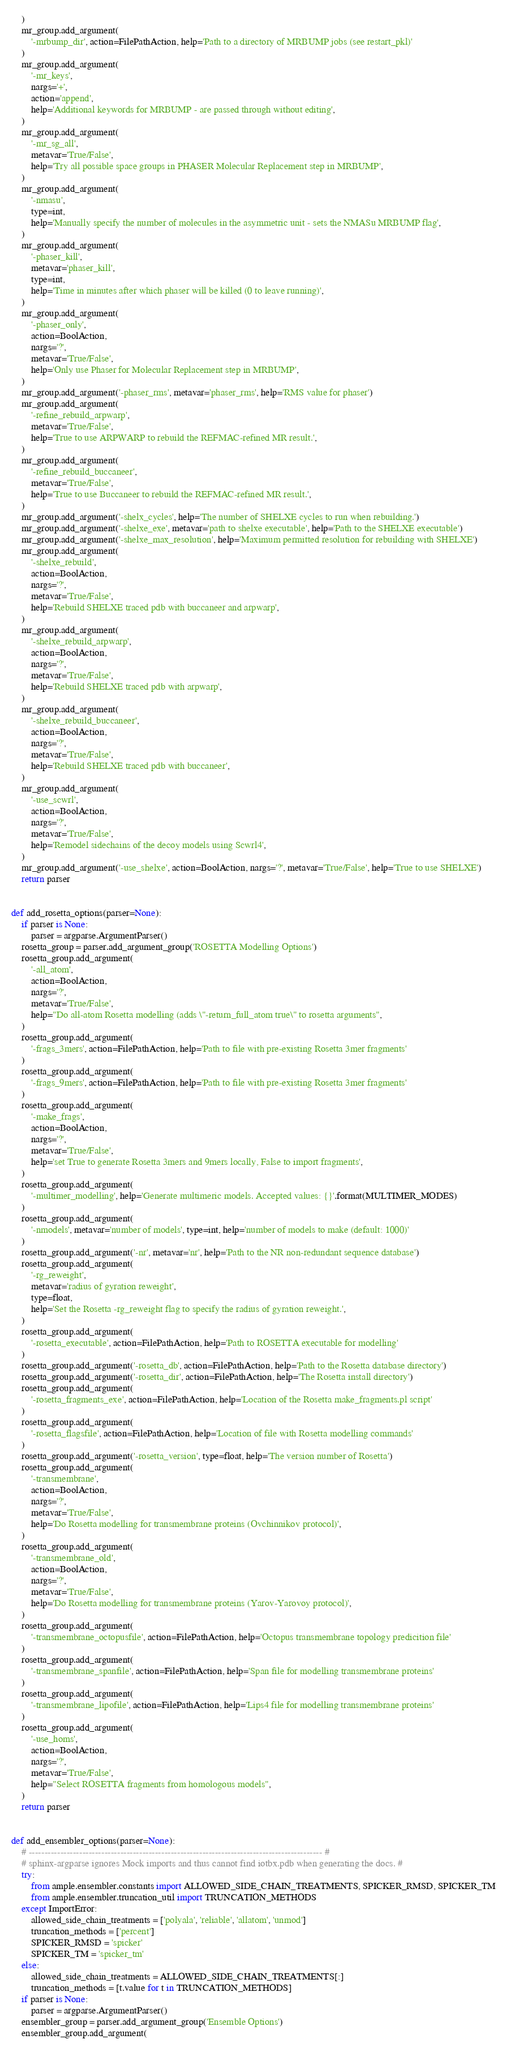<code> <loc_0><loc_0><loc_500><loc_500><_Python_>    )
    mr_group.add_argument(
        '-mrbump_dir', action=FilePathAction, help='Path to a directory of MRBUMP jobs (see restart_pkl)'
    )
    mr_group.add_argument(
        '-mr_keys',
        nargs='+',
        action='append',
        help='Additional keywords for MRBUMP - are passed through without editing',
    )
    mr_group.add_argument(
        '-mr_sg_all',
        metavar='True/False',
        help='Try all possible space groups in PHASER Molecular Replacement step in MRBUMP',
    )
    mr_group.add_argument(
        '-nmasu',
        type=int,
        help='Manually specify the number of molecules in the asymmetric unit - sets the NMASu MRBUMP flag',
    )
    mr_group.add_argument(
        '-phaser_kill',
        metavar='phaser_kill',
        type=int,
        help='Time in minutes after which phaser will be killed (0 to leave running)',
    )
    mr_group.add_argument(
        '-phaser_only',
        action=BoolAction,
        nargs='?',
        metavar='True/False',
        help='Only use Phaser for Molecular Replacement step in MRBUMP',
    )
    mr_group.add_argument('-phaser_rms', metavar='phaser_rms', help='RMS value for phaser')
    mr_group.add_argument(
        '-refine_rebuild_arpwarp',
        metavar='True/False',
        help='True to use ARPWARP to rebuild the REFMAC-refined MR result.',
    )
    mr_group.add_argument(
        '-refine_rebuild_buccaneer',
        metavar='True/False',
        help='True to use Buccaneer to rebuild the REFMAC-refined MR result.',
    )
    mr_group.add_argument('-shelx_cycles', help='The number of SHELXE cycles to run when rebuilding.')
    mr_group.add_argument('-shelxe_exe', metavar='path to shelxe executable', help='Path to the SHELXE executable')
    mr_group.add_argument('-shelxe_max_resolution', help='Maximum permitted resolution for rebuilding with SHELXE')
    mr_group.add_argument(
        '-shelxe_rebuild',
        action=BoolAction,
        nargs='?',
        metavar='True/False',
        help='Rebuild SHELXE traced pdb with buccaneer and arpwarp',
    )
    mr_group.add_argument(
        '-shelxe_rebuild_arpwarp',
        action=BoolAction,
        nargs='?',
        metavar='True/False',
        help='Rebuild SHELXE traced pdb with arpwarp',
    )
    mr_group.add_argument(
        '-shelxe_rebuild_buccaneer',
        action=BoolAction,
        nargs='?',
        metavar='True/False',
        help='Rebuild SHELXE traced pdb with buccaneer',
    )
    mr_group.add_argument(
        '-use_scwrl',
        action=BoolAction,
        nargs='?',
        metavar='True/False',
        help='Remodel sidechains of the decoy models using Scwrl4',
    )
    mr_group.add_argument('-use_shelxe', action=BoolAction, nargs='?', metavar='True/False', help='True to use SHELXE')
    return parser


def add_rosetta_options(parser=None):
    if parser is None:
        parser = argparse.ArgumentParser()
    rosetta_group = parser.add_argument_group('ROSETTA Modelling Options')
    rosetta_group.add_argument(
        '-all_atom',
        action=BoolAction,
        nargs='?',
        metavar='True/False',
        help="Do all-atom Rosetta modelling (adds \"-return_full_atom true\" to rosetta arguments",
    )
    rosetta_group.add_argument(
        '-frags_3mers', action=FilePathAction, help='Path to file with pre-existing Rosetta 3mer fragments'
    )
    rosetta_group.add_argument(
        '-frags_9mers', action=FilePathAction, help='Path to file with pre-existing Rosetta 3mer fragments'
    )
    rosetta_group.add_argument(
        '-make_frags',
        action=BoolAction,
        nargs='?',
        metavar='True/False',
        help='set True to generate Rosetta 3mers and 9mers locally, False to import fragments',
    )
    rosetta_group.add_argument(
        '-multimer_modelling', help='Generate multimeric models. Accepted values: {}'.format(MULTIMER_MODES)
    )
    rosetta_group.add_argument(
        '-nmodels', metavar='number of models', type=int, help='number of models to make (default: 1000)'
    )
    rosetta_group.add_argument('-nr', metavar='nr', help='Path to the NR non-redundant sequence database')
    rosetta_group.add_argument(
        '-rg_reweight',
        metavar='radius of gyration reweight',
        type=float,
        help='Set the Rosetta -rg_reweight flag to specify the radius of gyration reweight.',
    )
    rosetta_group.add_argument(
        '-rosetta_executable', action=FilePathAction, help='Path to ROSETTA executable for modelling'
    )
    rosetta_group.add_argument('-rosetta_db', action=FilePathAction, help='Path to the Rosetta database directory')
    rosetta_group.add_argument('-rosetta_dir', action=FilePathAction, help='The Rosetta install directory')
    rosetta_group.add_argument(
        '-rosetta_fragments_exe', action=FilePathAction, help='Location of the Rosetta make_fragments.pl script'
    )
    rosetta_group.add_argument(
        '-rosetta_flagsfile', action=FilePathAction, help='Location of file with Rosetta modelling commands'
    )
    rosetta_group.add_argument('-rosetta_version', type=float, help='The version number of Rosetta')
    rosetta_group.add_argument(
        '-transmembrane',
        action=BoolAction,
        nargs='?',
        metavar='True/False',
        help='Do Rosetta modelling for transmembrane proteins (Ovchinnikov protocol)',
    )
    rosetta_group.add_argument(
        '-transmembrane_old',
        action=BoolAction,
        nargs='?',
        metavar='True/False',
        help='Do Rosetta modelling for transmembrane proteins (Yarov-Yarovoy protocol)',
    )
    rosetta_group.add_argument(
        '-transmembrane_octopusfile', action=FilePathAction, help='Octopus transmembrane topology predicition file'
    )
    rosetta_group.add_argument(
        '-transmembrane_spanfile', action=FilePathAction, help='Span file for modelling transmembrane proteins'
    )
    rosetta_group.add_argument(
        '-transmembrane_lipofile', action=FilePathAction, help='Lips4 file for modelling transmembrane proteins'
    )
    rosetta_group.add_argument(
        '-use_homs',
        action=BoolAction,
        nargs='?',
        metavar='True/False',
        help="Select ROSETTA fragments from homologous models",
    )
    return parser


def add_ensembler_options(parser=None):
    # --------------------------------------------------------------------------------------------- #
    # sphinx-argparse ignores Mock imports and thus cannot find iotbx.pdb when generating the docs. #
    try:
        from ample.ensembler.constants import ALLOWED_SIDE_CHAIN_TREATMENTS, SPICKER_RMSD, SPICKER_TM
        from ample.ensembler.truncation_util import TRUNCATION_METHODS
    except ImportError:
        allowed_side_chain_treatments = ['polyala', 'reliable', 'allatom', 'unmod']
        truncation_methods = ['percent']
        SPICKER_RMSD = 'spicker'
        SPICKER_TM = 'spicker_tm'
    else:
        allowed_side_chain_treatments = ALLOWED_SIDE_CHAIN_TREATMENTS[:]
        truncation_methods = [t.value for t in TRUNCATION_METHODS]
    if parser is None:
        parser = argparse.ArgumentParser()
    ensembler_group = parser.add_argument_group('Ensemble Options')
    ensembler_group.add_argument(</code> 